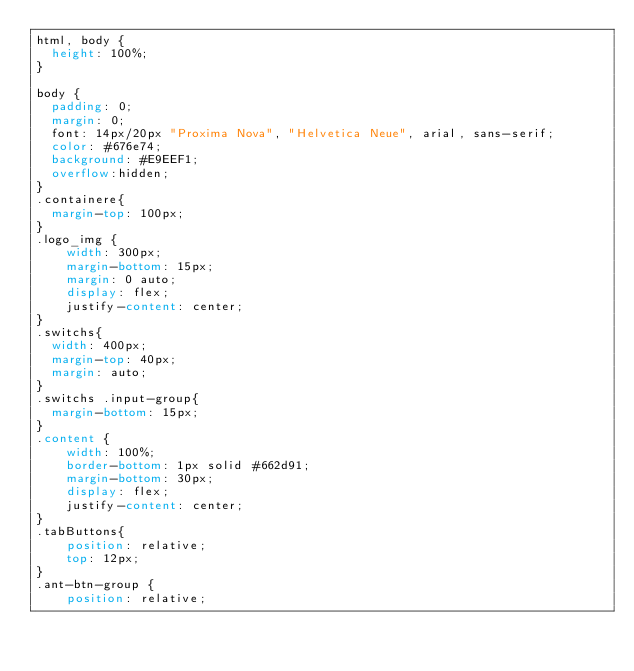Convert code to text. <code><loc_0><loc_0><loc_500><loc_500><_CSS_>html, body {
  height: 100%;
}

body {
  padding: 0;
  margin: 0;
  font: 14px/20px "Proxima Nova", "Helvetica Neue", arial, sans-serif;
  color: #676e74;
  background: #E9EEF1;
  overflow:hidden;
}
.containere{
  margin-top: 100px;
}
.logo_img {
    width: 300px;
    margin-bottom: 15px;
    margin: 0 auto;
    display: flex;
    justify-content: center;  
}
.switchs{
  width: 400px;
  margin-top: 40px;
  margin: auto;
}
.switchs .input-group{
  margin-bottom: 15px;
}
.content {
    width: 100%;
    border-bottom: 1px solid #662d91;
    margin-bottom: 30px;
    display: flex;
    justify-content: center;
}
.tabButtons{
    position: relative;
    top: 12px;
}
.ant-btn-group {
    position: relative;</code> 